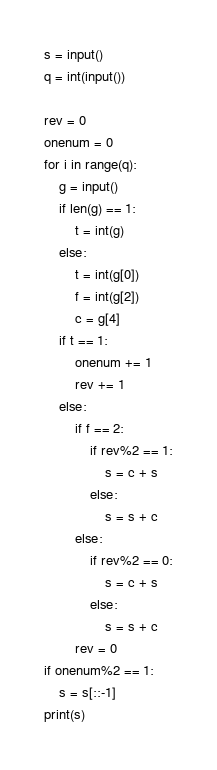Convert code to text. <code><loc_0><loc_0><loc_500><loc_500><_Python_>s = input()
q = int(input())

rev = 0
onenum = 0
for i in range(q):
	g = input()
	if len(g) == 1:
		t = int(g)
	else:
		t = int(g[0])
		f = int(g[2])
		c = g[4]
	if t == 1:
		onenum += 1
		rev += 1
	else:
		if f == 2:
			if rev%2 == 1:
				s = c + s
			else:
				s = s + c
		else:
			if rev%2 == 0:
				s = c + s
			else:
				s = s + c
		rev = 0
if onenum%2 == 1:
	s = s[::-1]
print(s)</code> 